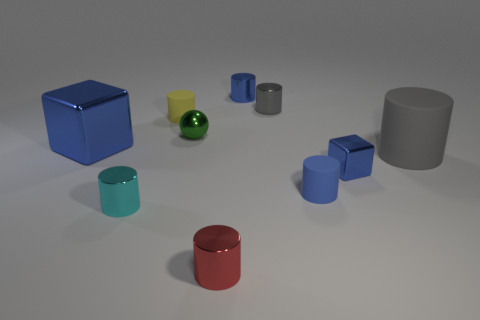Subtract all tiny cylinders. How many cylinders are left? 1 Subtract all purple cubes. How many blue cylinders are left? 2 Subtract all red cylinders. How many cylinders are left? 6 Subtract 1 cylinders. How many cylinders are left? 6 Subtract all balls. How many objects are left? 9 Subtract all green cylinders. Subtract all yellow spheres. How many cylinders are left? 7 Subtract all big red shiny cylinders. Subtract all cyan metal things. How many objects are left? 9 Add 7 yellow rubber cylinders. How many yellow rubber cylinders are left? 8 Add 9 large blue balls. How many large blue balls exist? 9 Subtract 0 cyan blocks. How many objects are left? 10 